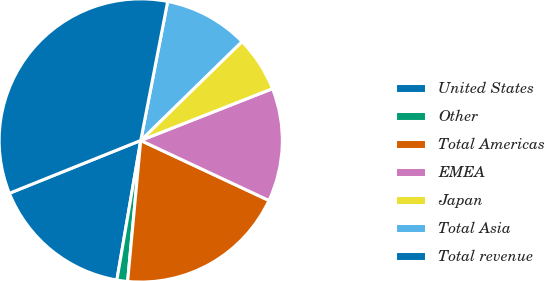Convert chart to OTSL. <chart><loc_0><loc_0><loc_500><loc_500><pie_chart><fcel>United States<fcel>Other<fcel>Total Americas<fcel>EMEA<fcel>Japan<fcel>Total Asia<fcel>Total revenue<nl><fcel>16.22%<fcel>1.22%<fcel>19.51%<fcel>12.93%<fcel>6.35%<fcel>9.64%<fcel>34.13%<nl></chart> 